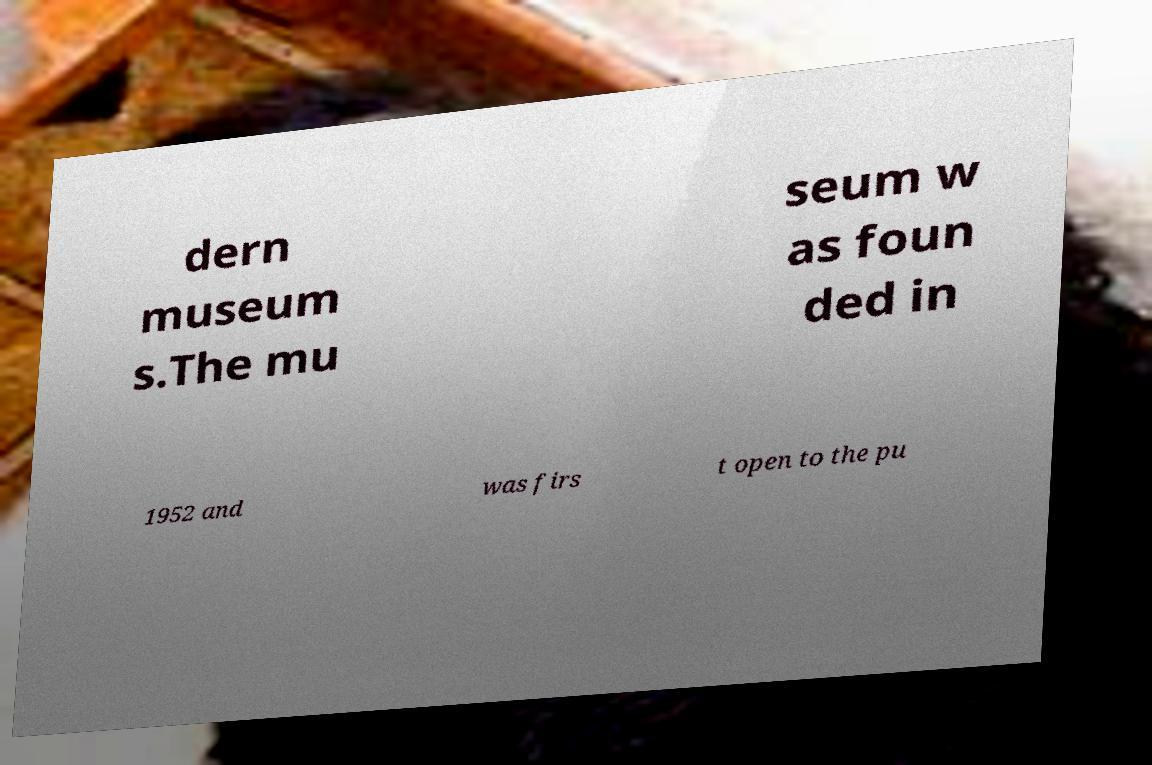Can you accurately transcribe the text from the provided image for me? dern museum s.The mu seum w as foun ded in 1952 and was firs t open to the pu 